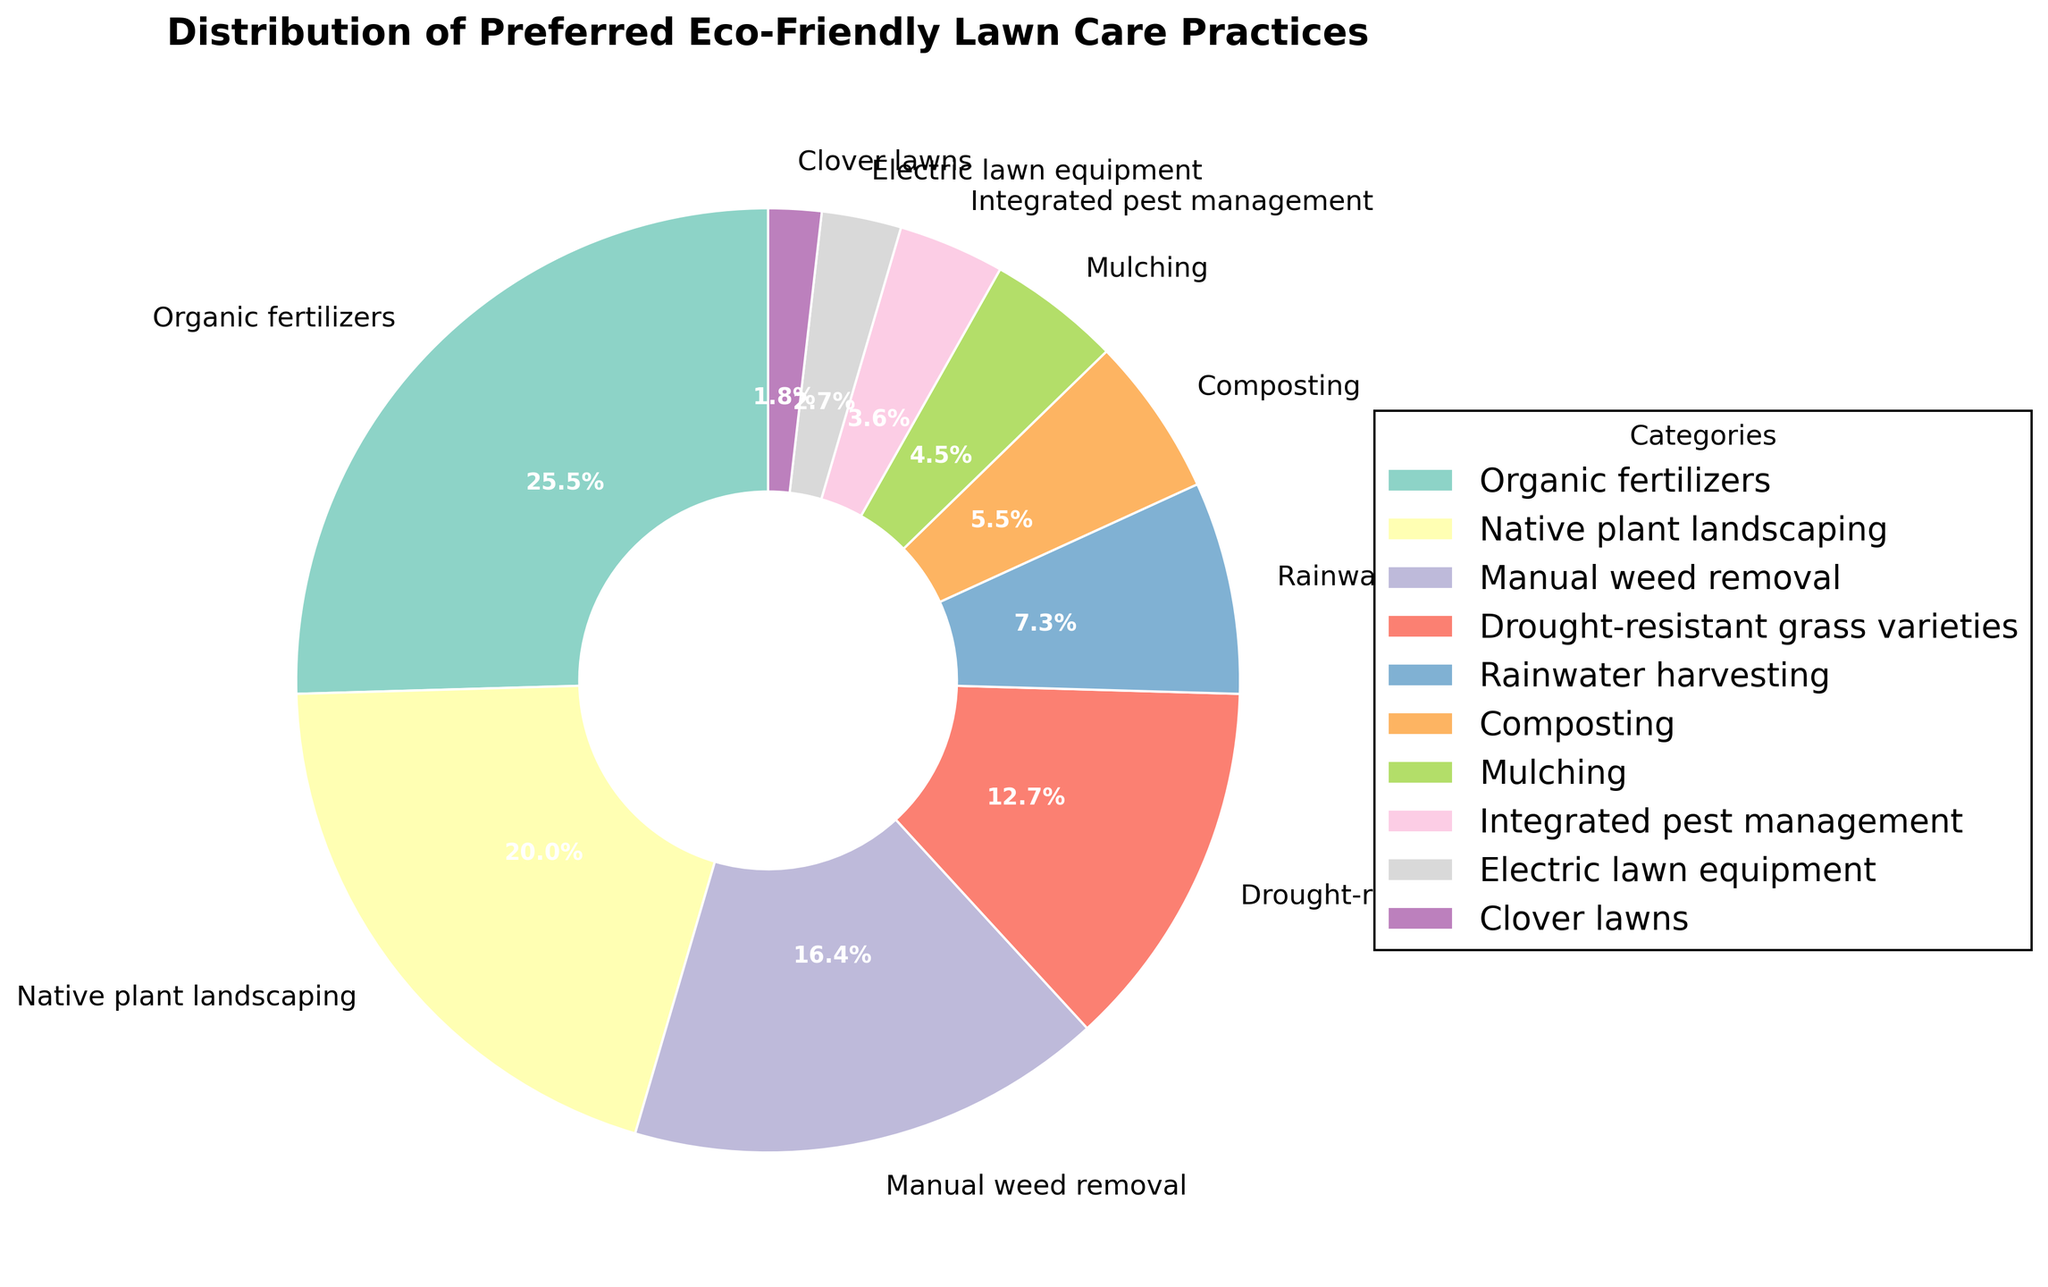Which eco-friendly lawn care practice is preferred by the highest percentage of homeowners? The pie chart shows various categories with their respective percentages. "Organic fertilizers" has the highest percentage at 28%.
Answer: Organic fertilizers Which two practices combined account for half of the homeowner's preferences? Adding the percentages of the two highest categories: Organic fertilizers (28%) + Native plant landscaping (22%) = 50%.
Answer: Organic fertilizers and Native plant landscaping Is the percentage of homeowners who prefer rainwater harvesting higher or lower than those who prefer mulching? According to the pie chart, rainwater harvesting is at 8% while mulching is 5%, so rainwater harvesting is higher.
Answer: Higher What is the total percentage of homeowners who prefer either manual weed removal or composting? Adding the percentages: Manual weed removal (18%) + Composting (6%) = 24%.
Answer: 24% How many practices have a preference of less than 10%? By scanning the pie chart, practices with less than 10% are: Rainwater harvesting (8%), Composting (6%), Mulching (5%), Integrated pest management (4%), Electric lawn equipment (3%), and Clover lawns (2%). There are 6 practices in total.
Answer: 6 Which practice has the least preference among homeowners? According to the pie chart, Clover lawns have the smallest slice, indicating a 2% preference, the least among all practices.
Answer: Clover lawns Are there more homeowners who prefer drought-resistant grass varieties compared to manual weed removal? The pie chart indicates drought-resistant grass varieties at 14% and manual weed removal at 18%. Manual weed removal has a higher preference.
Answer: No If you sum the preferences for Native plant landscaping, Mulching, and Electric lawn equipment, what percentage do you get? Adding the percentages: Native plant landscaping (22%) + Mulching (5%) + Electric lawn equipment (3%) = 30%.
Answer: 30% By how much does the preference for Native plant landscaping exceed that for Integrated pest management? Calculating the difference: Native plant landscaping (22%) - Integrated pest management (4%) = 18%.
Answer: 18% 